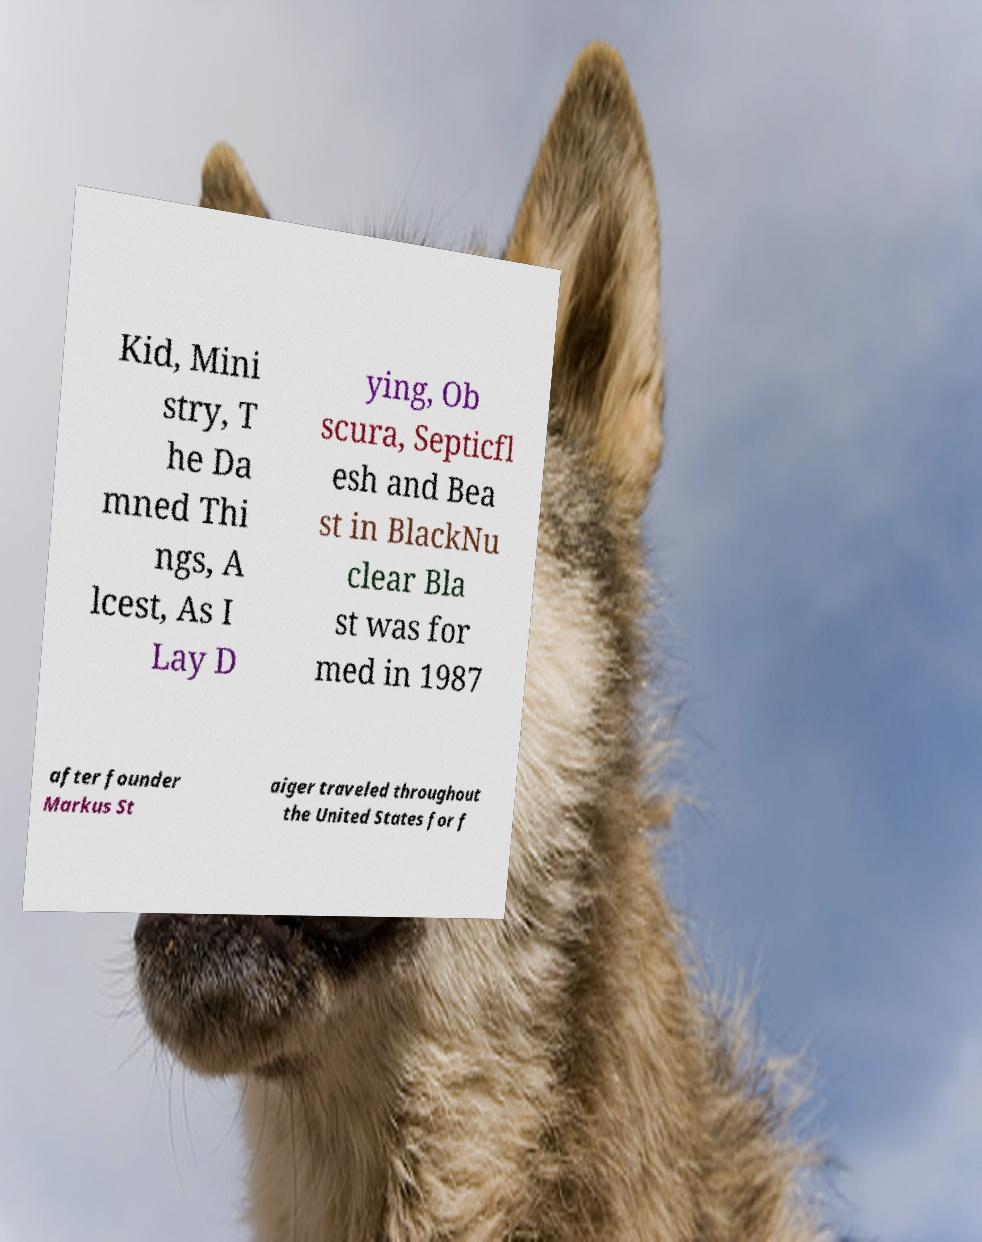Could you assist in decoding the text presented in this image and type it out clearly? Kid, Mini stry, T he Da mned Thi ngs, A lcest, As I Lay D ying, Ob scura, Septicfl esh and Bea st in BlackNu clear Bla st was for med in 1987 after founder Markus St aiger traveled throughout the United States for f 